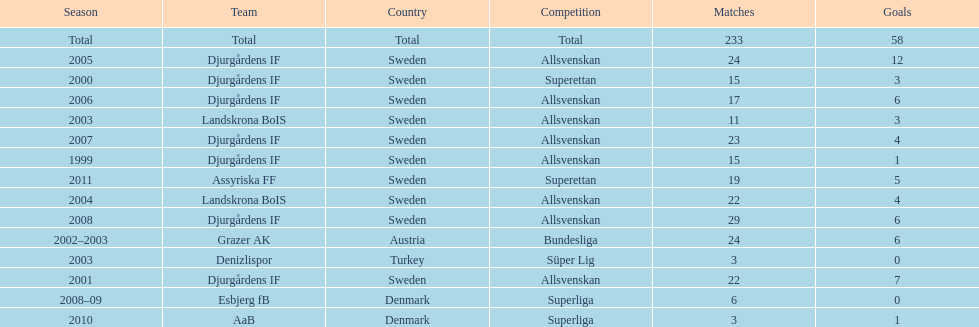How many teams had above 20 matches in the season? 6. 